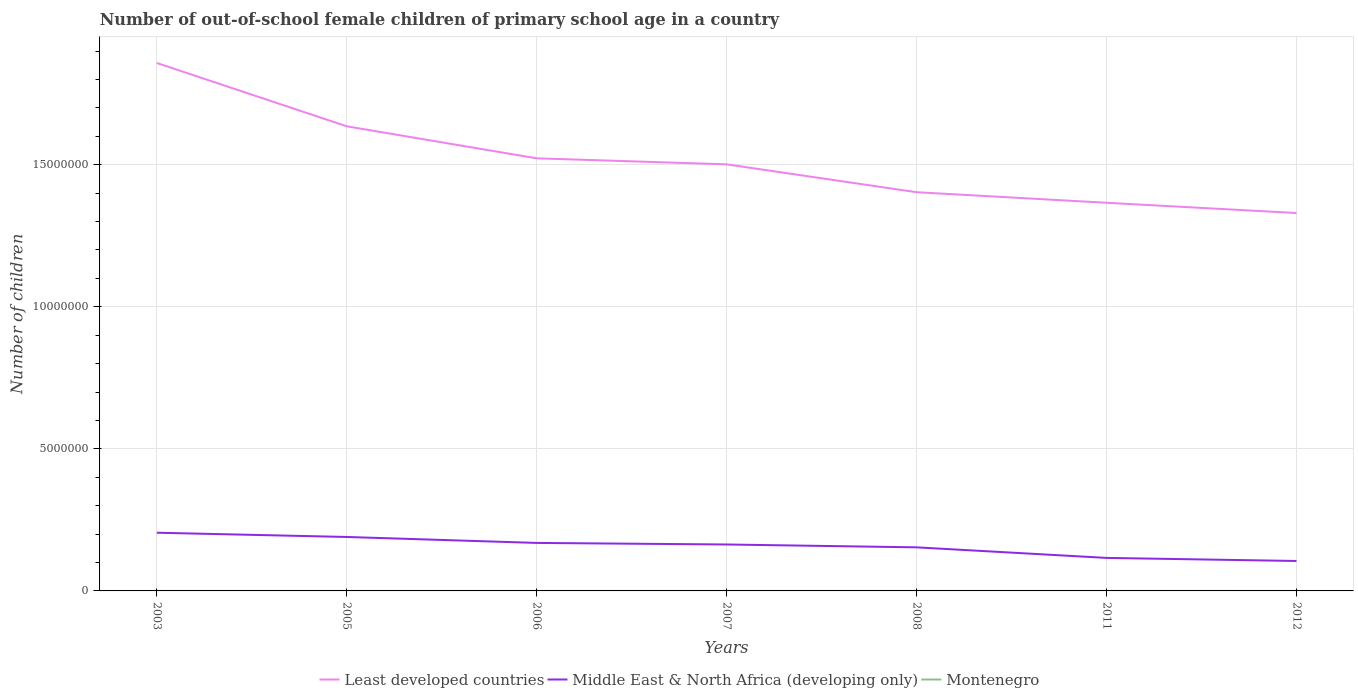Across all years, what is the maximum number of out-of-school female children in Least developed countries?
Give a very brief answer. 1.33e+07. In which year was the number of out-of-school female children in Middle East & North Africa (developing only) maximum?
Ensure brevity in your answer.  2012. What is the total number of out-of-school female children in Montenegro in the graph?
Your answer should be compact. -806. What is the difference between the highest and the second highest number of out-of-school female children in Montenegro?
Give a very brief answer. 1319. Is the number of out-of-school female children in Least developed countries strictly greater than the number of out-of-school female children in Middle East & North Africa (developing only) over the years?
Ensure brevity in your answer.  No. What is the difference between two consecutive major ticks on the Y-axis?
Your answer should be compact. 5.00e+06. Are the values on the major ticks of Y-axis written in scientific E-notation?
Your response must be concise. No. Does the graph contain grids?
Give a very brief answer. Yes. Where does the legend appear in the graph?
Ensure brevity in your answer.  Bottom center. How many legend labels are there?
Your response must be concise. 3. How are the legend labels stacked?
Keep it short and to the point. Horizontal. What is the title of the graph?
Offer a terse response. Number of out-of-school female children of primary school age in a country. What is the label or title of the X-axis?
Make the answer very short. Years. What is the label or title of the Y-axis?
Your answer should be very brief. Number of children. What is the Number of children of Least developed countries in 2003?
Provide a succinct answer. 1.86e+07. What is the Number of children of Middle East & North Africa (developing only) in 2003?
Make the answer very short. 2.05e+06. What is the Number of children in Montenegro in 2003?
Give a very brief answer. 666. What is the Number of children in Least developed countries in 2005?
Give a very brief answer. 1.64e+07. What is the Number of children of Middle East & North Africa (developing only) in 2005?
Your response must be concise. 1.90e+06. What is the Number of children of Montenegro in 2005?
Provide a short and direct response. 396. What is the Number of children in Least developed countries in 2006?
Ensure brevity in your answer.  1.52e+07. What is the Number of children in Middle East & North Africa (developing only) in 2006?
Ensure brevity in your answer.  1.69e+06. What is the Number of children of Montenegro in 2006?
Make the answer very short. 362. What is the Number of children in Least developed countries in 2007?
Give a very brief answer. 1.50e+07. What is the Number of children in Middle East & North Africa (developing only) in 2007?
Your answer should be very brief. 1.63e+06. What is the Number of children in Montenegro in 2007?
Give a very brief answer. 685. What is the Number of children of Least developed countries in 2008?
Ensure brevity in your answer.  1.40e+07. What is the Number of children of Middle East & North Africa (developing only) in 2008?
Give a very brief answer. 1.53e+06. What is the Number of children in Montenegro in 2008?
Your response must be concise. 690. What is the Number of children in Least developed countries in 2011?
Offer a very short reply. 1.37e+07. What is the Number of children of Middle East & North Africa (developing only) in 2011?
Your answer should be compact. 1.16e+06. What is the Number of children of Montenegro in 2011?
Provide a succinct answer. 1491. What is the Number of children of Least developed countries in 2012?
Make the answer very short. 1.33e+07. What is the Number of children in Middle East & North Africa (developing only) in 2012?
Offer a terse response. 1.05e+06. What is the Number of children in Montenegro in 2012?
Keep it short and to the point. 172. Across all years, what is the maximum Number of children of Least developed countries?
Provide a succinct answer. 1.86e+07. Across all years, what is the maximum Number of children in Middle East & North Africa (developing only)?
Offer a terse response. 2.05e+06. Across all years, what is the maximum Number of children in Montenegro?
Offer a terse response. 1491. Across all years, what is the minimum Number of children in Least developed countries?
Offer a very short reply. 1.33e+07. Across all years, what is the minimum Number of children of Middle East & North Africa (developing only)?
Your answer should be compact. 1.05e+06. Across all years, what is the minimum Number of children in Montenegro?
Make the answer very short. 172. What is the total Number of children in Least developed countries in the graph?
Offer a terse response. 1.06e+08. What is the total Number of children of Middle East & North Africa (developing only) in the graph?
Give a very brief answer. 1.10e+07. What is the total Number of children in Montenegro in the graph?
Provide a succinct answer. 4462. What is the difference between the Number of children in Least developed countries in 2003 and that in 2005?
Provide a short and direct response. 2.23e+06. What is the difference between the Number of children in Middle East & North Africa (developing only) in 2003 and that in 2005?
Ensure brevity in your answer.  1.49e+05. What is the difference between the Number of children of Montenegro in 2003 and that in 2005?
Offer a very short reply. 270. What is the difference between the Number of children of Least developed countries in 2003 and that in 2006?
Your response must be concise. 3.36e+06. What is the difference between the Number of children in Middle East & North Africa (developing only) in 2003 and that in 2006?
Offer a terse response. 3.59e+05. What is the difference between the Number of children in Montenegro in 2003 and that in 2006?
Offer a very short reply. 304. What is the difference between the Number of children of Least developed countries in 2003 and that in 2007?
Keep it short and to the point. 3.57e+06. What is the difference between the Number of children of Middle East & North Africa (developing only) in 2003 and that in 2007?
Offer a terse response. 4.14e+05. What is the difference between the Number of children of Least developed countries in 2003 and that in 2008?
Make the answer very short. 4.55e+06. What is the difference between the Number of children of Middle East & North Africa (developing only) in 2003 and that in 2008?
Your answer should be very brief. 5.14e+05. What is the difference between the Number of children in Least developed countries in 2003 and that in 2011?
Make the answer very short. 4.92e+06. What is the difference between the Number of children of Middle East & North Africa (developing only) in 2003 and that in 2011?
Provide a succinct answer. 8.86e+05. What is the difference between the Number of children in Montenegro in 2003 and that in 2011?
Keep it short and to the point. -825. What is the difference between the Number of children of Least developed countries in 2003 and that in 2012?
Give a very brief answer. 5.28e+06. What is the difference between the Number of children of Middle East & North Africa (developing only) in 2003 and that in 2012?
Make the answer very short. 9.95e+05. What is the difference between the Number of children of Montenegro in 2003 and that in 2012?
Offer a terse response. 494. What is the difference between the Number of children of Least developed countries in 2005 and that in 2006?
Provide a short and direct response. 1.13e+06. What is the difference between the Number of children in Middle East & North Africa (developing only) in 2005 and that in 2006?
Your response must be concise. 2.09e+05. What is the difference between the Number of children in Least developed countries in 2005 and that in 2007?
Give a very brief answer. 1.34e+06. What is the difference between the Number of children in Middle East & North Africa (developing only) in 2005 and that in 2007?
Give a very brief answer. 2.65e+05. What is the difference between the Number of children in Montenegro in 2005 and that in 2007?
Your response must be concise. -289. What is the difference between the Number of children in Least developed countries in 2005 and that in 2008?
Keep it short and to the point. 2.32e+06. What is the difference between the Number of children in Middle East & North Africa (developing only) in 2005 and that in 2008?
Offer a very short reply. 3.65e+05. What is the difference between the Number of children of Montenegro in 2005 and that in 2008?
Your response must be concise. -294. What is the difference between the Number of children in Least developed countries in 2005 and that in 2011?
Your answer should be compact. 2.69e+06. What is the difference between the Number of children of Middle East & North Africa (developing only) in 2005 and that in 2011?
Provide a short and direct response. 7.37e+05. What is the difference between the Number of children in Montenegro in 2005 and that in 2011?
Your response must be concise. -1095. What is the difference between the Number of children in Least developed countries in 2005 and that in 2012?
Ensure brevity in your answer.  3.05e+06. What is the difference between the Number of children in Middle East & North Africa (developing only) in 2005 and that in 2012?
Provide a short and direct response. 8.45e+05. What is the difference between the Number of children of Montenegro in 2005 and that in 2012?
Provide a succinct answer. 224. What is the difference between the Number of children in Least developed countries in 2006 and that in 2007?
Keep it short and to the point. 2.11e+05. What is the difference between the Number of children in Middle East & North Africa (developing only) in 2006 and that in 2007?
Offer a very short reply. 5.52e+04. What is the difference between the Number of children in Montenegro in 2006 and that in 2007?
Give a very brief answer. -323. What is the difference between the Number of children in Least developed countries in 2006 and that in 2008?
Ensure brevity in your answer.  1.19e+06. What is the difference between the Number of children of Middle East & North Africa (developing only) in 2006 and that in 2008?
Make the answer very short. 1.56e+05. What is the difference between the Number of children in Montenegro in 2006 and that in 2008?
Provide a short and direct response. -328. What is the difference between the Number of children of Least developed countries in 2006 and that in 2011?
Provide a short and direct response. 1.56e+06. What is the difference between the Number of children in Middle East & North Africa (developing only) in 2006 and that in 2011?
Your response must be concise. 5.27e+05. What is the difference between the Number of children of Montenegro in 2006 and that in 2011?
Your answer should be very brief. -1129. What is the difference between the Number of children in Least developed countries in 2006 and that in 2012?
Provide a short and direct response. 1.93e+06. What is the difference between the Number of children of Middle East & North Africa (developing only) in 2006 and that in 2012?
Provide a succinct answer. 6.36e+05. What is the difference between the Number of children in Montenegro in 2006 and that in 2012?
Offer a terse response. 190. What is the difference between the Number of children in Least developed countries in 2007 and that in 2008?
Your answer should be very brief. 9.81e+05. What is the difference between the Number of children in Middle East & North Africa (developing only) in 2007 and that in 2008?
Give a very brief answer. 1.00e+05. What is the difference between the Number of children of Montenegro in 2007 and that in 2008?
Your answer should be very brief. -5. What is the difference between the Number of children of Least developed countries in 2007 and that in 2011?
Make the answer very short. 1.35e+06. What is the difference between the Number of children of Middle East & North Africa (developing only) in 2007 and that in 2011?
Make the answer very short. 4.72e+05. What is the difference between the Number of children of Montenegro in 2007 and that in 2011?
Your response must be concise. -806. What is the difference between the Number of children of Least developed countries in 2007 and that in 2012?
Offer a terse response. 1.71e+06. What is the difference between the Number of children in Middle East & North Africa (developing only) in 2007 and that in 2012?
Make the answer very short. 5.81e+05. What is the difference between the Number of children in Montenegro in 2007 and that in 2012?
Give a very brief answer. 513. What is the difference between the Number of children of Least developed countries in 2008 and that in 2011?
Your answer should be compact. 3.72e+05. What is the difference between the Number of children in Middle East & North Africa (developing only) in 2008 and that in 2011?
Give a very brief answer. 3.72e+05. What is the difference between the Number of children in Montenegro in 2008 and that in 2011?
Keep it short and to the point. -801. What is the difference between the Number of children in Least developed countries in 2008 and that in 2012?
Your answer should be compact. 7.33e+05. What is the difference between the Number of children of Middle East & North Africa (developing only) in 2008 and that in 2012?
Provide a succinct answer. 4.80e+05. What is the difference between the Number of children of Montenegro in 2008 and that in 2012?
Ensure brevity in your answer.  518. What is the difference between the Number of children in Least developed countries in 2011 and that in 2012?
Give a very brief answer. 3.61e+05. What is the difference between the Number of children of Middle East & North Africa (developing only) in 2011 and that in 2012?
Offer a terse response. 1.09e+05. What is the difference between the Number of children in Montenegro in 2011 and that in 2012?
Give a very brief answer. 1319. What is the difference between the Number of children of Least developed countries in 2003 and the Number of children of Middle East & North Africa (developing only) in 2005?
Offer a very short reply. 1.67e+07. What is the difference between the Number of children of Least developed countries in 2003 and the Number of children of Montenegro in 2005?
Offer a terse response. 1.86e+07. What is the difference between the Number of children of Middle East & North Africa (developing only) in 2003 and the Number of children of Montenegro in 2005?
Offer a very short reply. 2.05e+06. What is the difference between the Number of children of Least developed countries in 2003 and the Number of children of Middle East & North Africa (developing only) in 2006?
Provide a short and direct response. 1.69e+07. What is the difference between the Number of children in Least developed countries in 2003 and the Number of children in Montenegro in 2006?
Offer a very short reply. 1.86e+07. What is the difference between the Number of children in Middle East & North Africa (developing only) in 2003 and the Number of children in Montenegro in 2006?
Offer a very short reply. 2.05e+06. What is the difference between the Number of children of Least developed countries in 2003 and the Number of children of Middle East & North Africa (developing only) in 2007?
Your answer should be compact. 1.69e+07. What is the difference between the Number of children of Least developed countries in 2003 and the Number of children of Montenegro in 2007?
Offer a very short reply. 1.86e+07. What is the difference between the Number of children in Middle East & North Africa (developing only) in 2003 and the Number of children in Montenegro in 2007?
Give a very brief answer. 2.05e+06. What is the difference between the Number of children in Least developed countries in 2003 and the Number of children in Middle East & North Africa (developing only) in 2008?
Give a very brief answer. 1.70e+07. What is the difference between the Number of children of Least developed countries in 2003 and the Number of children of Montenegro in 2008?
Keep it short and to the point. 1.86e+07. What is the difference between the Number of children in Middle East & North Africa (developing only) in 2003 and the Number of children in Montenegro in 2008?
Offer a very short reply. 2.05e+06. What is the difference between the Number of children of Least developed countries in 2003 and the Number of children of Middle East & North Africa (developing only) in 2011?
Offer a terse response. 1.74e+07. What is the difference between the Number of children of Least developed countries in 2003 and the Number of children of Montenegro in 2011?
Give a very brief answer. 1.86e+07. What is the difference between the Number of children of Middle East & North Africa (developing only) in 2003 and the Number of children of Montenegro in 2011?
Keep it short and to the point. 2.05e+06. What is the difference between the Number of children of Least developed countries in 2003 and the Number of children of Middle East & North Africa (developing only) in 2012?
Keep it short and to the point. 1.75e+07. What is the difference between the Number of children of Least developed countries in 2003 and the Number of children of Montenegro in 2012?
Offer a very short reply. 1.86e+07. What is the difference between the Number of children in Middle East & North Africa (developing only) in 2003 and the Number of children in Montenegro in 2012?
Your answer should be compact. 2.05e+06. What is the difference between the Number of children in Least developed countries in 2005 and the Number of children in Middle East & North Africa (developing only) in 2006?
Keep it short and to the point. 1.47e+07. What is the difference between the Number of children in Least developed countries in 2005 and the Number of children in Montenegro in 2006?
Your response must be concise. 1.64e+07. What is the difference between the Number of children in Middle East & North Africa (developing only) in 2005 and the Number of children in Montenegro in 2006?
Keep it short and to the point. 1.90e+06. What is the difference between the Number of children of Least developed countries in 2005 and the Number of children of Middle East & North Africa (developing only) in 2007?
Offer a terse response. 1.47e+07. What is the difference between the Number of children in Least developed countries in 2005 and the Number of children in Montenegro in 2007?
Ensure brevity in your answer.  1.64e+07. What is the difference between the Number of children in Middle East & North Africa (developing only) in 2005 and the Number of children in Montenegro in 2007?
Offer a very short reply. 1.90e+06. What is the difference between the Number of children in Least developed countries in 2005 and the Number of children in Middle East & North Africa (developing only) in 2008?
Make the answer very short. 1.48e+07. What is the difference between the Number of children of Least developed countries in 2005 and the Number of children of Montenegro in 2008?
Offer a very short reply. 1.64e+07. What is the difference between the Number of children in Middle East & North Africa (developing only) in 2005 and the Number of children in Montenegro in 2008?
Ensure brevity in your answer.  1.90e+06. What is the difference between the Number of children of Least developed countries in 2005 and the Number of children of Middle East & North Africa (developing only) in 2011?
Keep it short and to the point. 1.52e+07. What is the difference between the Number of children in Least developed countries in 2005 and the Number of children in Montenegro in 2011?
Your answer should be compact. 1.63e+07. What is the difference between the Number of children of Middle East & North Africa (developing only) in 2005 and the Number of children of Montenegro in 2011?
Your response must be concise. 1.90e+06. What is the difference between the Number of children in Least developed countries in 2005 and the Number of children in Middle East & North Africa (developing only) in 2012?
Provide a short and direct response. 1.53e+07. What is the difference between the Number of children in Least developed countries in 2005 and the Number of children in Montenegro in 2012?
Your response must be concise. 1.64e+07. What is the difference between the Number of children of Middle East & North Africa (developing only) in 2005 and the Number of children of Montenegro in 2012?
Your answer should be very brief. 1.90e+06. What is the difference between the Number of children of Least developed countries in 2006 and the Number of children of Middle East & North Africa (developing only) in 2007?
Provide a short and direct response. 1.36e+07. What is the difference between the Number of children in Least developed countries in 2006 and the Number of children in Montenegro in 2007?
Offer a very short reply. 1.52e+07. What is the difference between the Number of children in Middle East & North Africa (developing only) in 2006 and the Number of children in Montenegro in 2007?
Provide a succinct answer. 1.69e+06. What is the difference between the Number of children in Least developed countries in 2006 and the Number of children in Middle East & North Africa (developing only) in 2008?
Give a very brief answer. 1.37e+07. What is the difference between the Number of children in Least developed countries in 2006 and the Number of children in Montenegro in 2008?
Your answer should be very brief. 1.52e+07. What is the difference between the Number of children in Middle East & North Africa (developing only) in 2006 and the Number of children in Montenegro in 2008?
Offer a terse response. 1.69e+06. What is the difference between the Number of children in Least developed countries in 2006 and the Number of children in Middle East & North Africa (developing only) in 2011?
Your answer should be very brief. 1.41e+07. What is the difference between the Number of children in Least developed countries in 2006 and the Number of children in Montenegro in 2011?
Offer a terse response. 1.52e+07. What is the difference between the Number of children in Middle East & North Africa (developing only) in 2006 and the Number of children in Montenegro in 2011?
Ensure brevity in your answer.  1.69e+06. What is the difference between the Number of children of Least developed countries in 2006 and the Number of children of Middle East & North Africa (developing only) in 2012?
Provide a succinct answer. 1.42e+07. What is the difference between the Number of children in Least developed countries in 2006 and the Number of children in Montenegro in 2012?
Provide a succinct answer. 1.52e+07. What is the difference between the Number of children of Middle East & North Africa (developing only) in 2006 and the Number of children of Montenegro in 2012?
Your answer should be compact. 1.69e+06. What is the difference between the Number of children in Least developed countries in 2007 and the Number of children in Middle East & North Africa (developing only) in 2008?
Your answer should be very brief. 1.35e+07. What is the difference between the Number of children in Least developed countries in 2007 and the Number of children in Montenegro in 2008?
Your answer should be very brief. 1.50e+07. What is the difference between the Number of children of Middle East & North Africa (developing only) in 2007 and the Number of children of Montenegro in 2008?
Keep it short and to the point. 1.63e+06. What is the difference between the Number of children in Least developed countries in 2007 and the Number of children in Middle East & North Africa (developing only) in 2011?
Offer a terse response. 1.39e+07. What is the difference between the Number of children in Least developed countries in 2007 and the Number of children in Montenegro in 2011?
Give a very brief answer. 1.50e+07. What is the difference between the Number of children of Middle East & North Africa (developing only) in 2007 and the Number of children of Montenegro in 2011?
Your response must be concise. 1.63e+06. What is the difference between the Number of children in Least developed countries in 2007 and the Number of children in Middle East & North Africa (developing only) in 2012?
Give a very brief answer. 1.40e+07. What is the difference between the Number of children in Least developed countries in 2007 and the Number of children in Montenegro in 2012?
Ensure brevity in your answer.  1.50e+07. What is the difference between the Number of children in Middle East & North Africa (developing only) in 2007 and the Number of children in Montenegro in 2012?
Give a very brief answer. 1.63e+06. What is the difference between the Number of children of Least developed countries in 2008 and the Number of children of Middle East & North Africa (developing only) in 2011?
Offer a terse response. 1.29e+07. What is the difference between the Number of children of Least developed countries in 2008 and the Number of children of Montenegro in 2011?
Make the answer very short. 1.40e+07. What is the difference between the Number of children of Middle East & North Africa (developing only) in 2008 and the Number of children of Montenegro in 2011?
Offer a terse response. 1.53e+06. What is the difference between the Number of children of Least developed countries in 2008 and the Number of children of Middle East & North Africa (developing only) in 2012?
Your answer should be compact. 1.30e+07. What is the difference between the Number of children of Least developed countries in 2008 and the Number of children of Montenegro in 2012?
Keep it short and to the point. 1.40e+07. What is the difference between the Number of children of Middle East & North Africa (developing only) in 2008 and the Number of children of Montenegro in 2012?
Make the answer very short. 1.53e+06. What is the difference between the Number of children in Least developed countries in 2011 and the Number of children in Middle East & North Africa (developing only) in 2012?
Offer a terse response. 1.26e+07. What is the difference between the Number of children in Least developed countries in 2011 and the Number of children in Montenegro in 2012?
Your response must be concise. 1.37e+07. What is the difference between the Number of children of Middle East & North Africa (developing only) in 2011 and the Number of children of Montenegro in 2012?
Ensure brevity in your answer.  1.16e+06. What is the average Number of children in Least developed countries per year?
Your answer should be compact. 1.52e+07. What is the average Number of children in Middle East & North Africa (developing only) per year?
Make the answer very short. 1.57e+06. What is the average Number of children in Montenegro per year?
Provide a succinct answer. 637.43. In the year 2003, what is the difference between the Number of children of Least developed countries and Number of children of Middle East & North Africa (developing only)?
Give a very brief answer. 1.65e+07. In the year 2003, what is the difference between the Number of children of Least developed countries and Number of children of Montenegro?
Provide a succinct answer. 1.86e+07. In the year 2003, what is the difference between the Number of children in Middle East & North Africa (developing only) and Number of children in Montenegro?
Ensure brevity in your answer.  2.05e+06. In the year 2005, what is the difference between the Number of children of Least developed countries and Number of children of Middle East & North Africa (developing only)?
Make the answer very short. 1.45e+07. In the year 2005, what is the difference between the Number of children of Least developed countries and Number of children of Montenegro?
Ensure brevity in your answer.  1.64e+07. In the year 2005, what is the difference between the Number of children of Middle East & North Africa (developing only) and Number of children of Montenegro?
Give a very brief answer. 1.90e+06. In the year 2006, what is the difference between the Number of children of Least developed countries and Number of children of Middle East & North Africa (developing only)?
Your answer should be compact. 1.35e+07. In the year 2006, what is the difference between the Number of children of Least developed countries and Number of children of Montenegro?
Offer a terse response. 1.52e+07. In the year 2006, what is the difference between the Number of children of Middle East & North Africa (developing only) and Number of children of Montenegro?
Your response must be concise. 1.69e+06. In the year 2007, what is the difference between the Number of children of Least developed countries and Number of children of Middle East & North Africa (developing only)?
Keep it short and to the point. 1.34e+07. In the year 2007, what is the difference between the Number of children in Least developed countries and Number of children in Montenegro?
Keep it short and to the point. 1.50e+07. In the year 2007, what is the difference between the Number of children of Middle East & North Africa (developing only) and Number of children of Montenegro?
Your answer should be very brief. 1.63e+06. In the year 2008, what is the difference between the Number of children of Least developed countries and Number of children of Middle East & North Africa (developing only)?
Offer a very short reply. 1.25e+07. In the year 2008, what is the difference between the Number of children in Least developed countries and Number of children in Montenegro?
Give a very brief answer. 1.40e+07. In the year 2008, what is the difference between the Number of children in Middle East & North Africa (developing only) and Number of children in Montenegro?
Ensure brevity in your answer.  1.53e+06. In the year 2011, what is the difference between the Number of children in Least developed countries and Number of children in Middle East & North Africa (developing only)?
Ensure brevity in your answer.  1.25e+07. In the year 2011, what is the difference between the Number of children in Least developed countries and Number of children in Montenegro?
Provide a succinct answer. 1.37e+07. In the year 2011, what is the difference between the Number of children of Middle East & North Africa (developing only) and Number of children of Montenegro?
Keep it short and to the point. 1.16e+06. In the year 2012, what is the difference between the Number of children of Least developed countries and Number of children of Middle East & North Africa (developing only)?
Your answer should be compact. 1.22e+07. In the year 2012, what is the difference between the Number of children of Least developed countries and Number of children of Montenegro?
Your answer should be compact. 1.33e+07. In the year 2012, what is the difference between the Number of children of Middle East & North Africa (developing only) and Number of children of Montenegro?
Ensure brevity in your answer.  1.05e+06. What is the ratio of the Number of children in Least developed countries in 2003 to that in 2005?
Your answer should be very brief. 1.14. What is the ratio of the Number of children of Middle East & North Africa (developing only) in 2003 to that in 2005?
Your answer should be compact. 1.08. What is the ratio of the Number of children in Montenegro in 2003 to that in 2005?
Provide a short and direct response. 1.68. What is the ratio of the Number of children of Least developed countries in 2003 to that in 2006?
Ensure brevity in your answer.  1.22. What is the ratio of the Number of children in Middle East & North Africa (developing only) in 2003 to that in 2006?
Provide a short and direct response. 1.21. What is the ratio of the Number of children in Montenegro in 2003 to that in 2006?
Offer a terse response. 1.84. What is the ratio of the Number of children of Least developed countries in 2003 to that in 2007?
Ensure brevity in your answer.  1.24. What is the ratio of the Number of children of Middle East & North Africa (developing only) in 2003 to that in 2007?
Your answer should be compact. 1.25. What is the ratio of the Number of children in Montenegro in 2003 to that in 2007?
Ensure brevity in your answer.  0.97. What is the ratio of the Number of children in Least developed countries in 2003 to that in 2008?
Offer a very short reply. 1.32. What is the ratio of the Number of children in Middle East & North Africa (developing only) in 2003 to that in 2008?
Ensure brevity in your answer.  1.34. What is the ratio of the Number of children of Montenegro in 2003 to that in 2008?
Make the answer very short. 0.97. What is the ratio of the Number of children in Least developed countries in 2003 to that in 2011?
Keep it short and to the point. 1.36. What is the ratio of the Number of children of Middle East & North Africa (developing only) in 2003 to that in 2011?
Give a very brief answer. 1.76. What is the ratio of the Number of children in Montenegro in 2003 to that in 2011?
Keep it short and to the point. 0.45. What is the ratio of the Number of children in Least developed countries in 2003 to that in 2012?
Provide a succinct answer. 1.4. What is the ratio of the Number of children of Middle East & North Africa (developing only) in 2003 to that in 2012?
Your response must be concise. 1.94. What is the ratio of the Number of children in Montenegro in 2003 to that in 2012?
Provide a short and direct response. 3.87. What is the ratio of the Number of children in Least developed countries in 2005 to that in 2006?
Offer a very short reply. 1.07. What is the ratio of the Number of children of Middle East & North Africa (developing only) in 2005 to that in 2006?
Provide a short and direct response. 1.12. What is the ratio of the Number of children in Montenegro in 2005 to that in 2006?
Your response must be concise. 1.09. What is the ratio of the Number of children in Least developed countries in 2005 to that in 2007?
Ensure brevity in your answer.  1.09. What is the ratio of the Number of children of Middle East & North Africa (developing only) in 2005 to that in 2007?
Offer a terse response. 1.16. What is the ratio of the Number of children of Montenegro in 2005 to that in 2007?
Make the answer very short. 0.58. What is the ratio of the Number of children in Least developed countries in 2005 to that in 2008?
Your answer should be compact. 1.17. What is the ratio of the Number of children of Middle East & North Africa (developing only) in 2005 to that in 2008?
Make the answer very short. 1.24. What is the ratio of the Number of children in Montenegro in 2005 to that in 2008?
Keep it short and to the point. 0.57. What is the ratio of the Number of children in Least developed countries in 2005 to that in 2011?
Make the answer very short. 1.2. What is the ratio of the Number of children of Middle East & North Africa (developing only) in 2005 to that in 2011?
Make the answer very short. 1.63. What is the ratio of the Number of children of Montenegro in 2005 to that in 2011?
Keep it short and to the point. 0.27. What is the ratio of the Number of children of Least developed countries in 2005 to that in 2012?
Make the answer very short. 1.23. What is the ratio of the Number of children of Middle East & North Africa (developing only) in 2005 to that in 2012?
Your answer should be compact. 1.8. What is the ratio of the Number of children in Montenegro in 2005 to that in 2012?
Give a very brief answer. 2.3. What is the ratio of the Number of children of Least developed countries in 2006 to that in 2007?
Keep it short and to the point. 1.01. What is the ratio of the Number of children of Middle East & North Africa (developing only) in 2006 to that in 2007?
Your response must be concise. 1.03. What is the ratio of the Number of children of Montenegro in 2006 to that in 2007?
Make the answer very short. 0.53. What is the ratio of the Number of children in Least developed countries in 2006 to that in 2008?
Ensure brevity in your answer.  1.08. What is the ratio of the Number of children in Middle East & North Africa (developing only) in 2006 to that in 2008?
Give a very brief answer. 1.1. What is the ratio of the Number of children of Montenegro in 2006 to that in 2008?
Offer a very short reply. 0.52. What is the ratio of the Number of children in Least developed countries in 2006 to that in 2011?
Keep it short and to the point. 1.11. What is the ratio of the Number of children of Middle East & North Africa (developing only) in 2006 to that in 2011?
Provide a succinct answer. 1.45. What is the ratio of the Number of children in Montenegro in 2006 to that in 2011?
Make the answer very short. 0.24. What is the ratio of the Number of children in Least developed countries in 2006 to that in 2012?
Provide a short and direct response. 1.14. What is the ratio of the Number of children of Middle East & North Africa (developing only) in 2006 to that in 2012?
Offer a terse response. 1.6. What is the ratio of the Number of children of Montenegro in 2006 to that in 2012?
Ensure brevity in your answer.  2.1. What is the ratio of the Number of children in Least developed countries in 2007 to that in 2008?
Give a very brief answer. 1.07. What is the ratio of the Number of children in Middle East & North Africa (developing only) in 2007 to that in 2008?
Keep it short and to the point. 1.07. What is the ratio of the Number of children of Least developed countries in 2007 to that in 2011?
Your response must be concise. 1.1. What is the ratio of the Number of children of Middle East & North Africa (developing only) in 2007 to that in 2011?
Make the answer very short. 1.41. What is the ratio of the Number of children in Montenegro in 2007 to that in 2011?
Give a very brief answer. 0.46. What is the ratio of the Number of children of Least developed countries in 2007 to that in 2012?
Make the answer very short. 1.13. What is the ratio of the Number of children of Middle East & North Africa (developing only) in 2007 to that in 2012?
Keep it short and to the point. 1.55. What is the ratio of the Number of children of Montenegro in 2007 to that in 2012?
Provide a short and direct response. 3.98. What is the ratio of the Number of children in Least developed countries in 2008 to that in 2011?
Offer a very short reply. 1.03. What is the ratio of the Number of children in Middle East & North Africa (developing only) in 2008 to that in 2011?
Provide a succinct answer. 1.32. What is the ratio of the Number of children in Montenegro in 2008 to that in 2011?
Make the answer very short. 0.46. What is the ratio of the Number of children of Least developed countries in 2008 to that in 2012?
Ensure brevity in your answer.  1.06. What is the ratio of the Number of children of Middle East & North Africa (developing only) in 2008 to that in 2012?
Offer a terse response. 1.46. What is the ratio of the Number of children in Montenegro in 2008 to that in 2012?
Your response must be concise. 4.01. What is the ratio of the Number of children of Least developed countries in 2011 to that in 2012?
Your response must be concise. 1.03. What is the ratio of the Number of children in Middle East & North Africa (developing only) in 2011 to that in 2012?
Offer a very short reply. 1.1. What is the ratio of the Number of children of Montenegro in 2011 to that in 2012?
Give a very brief answer. 8.67. What is the difference between the highest and the second highest Number of children in Least developed countries?
Offer a terse response. 2.23e+06. What is the difference between the highest and the second highest Number of children of Middle East & North Africa (developing only)?
Give a very brief answer. 1.49e+05. What is the difference between the highest and the second highest Number of children of Montenegro?
Offer a terse response. 801. What is the difference between the highest and the lowest Number of children of Least developed countries?
Ensure brevity in your answer.  5.28e+06. What is the difference between the highest and the lowest Number of children in Middle East & North Africa (developing only)?
Give a very brief answer. 9.95e+05. What is the difference between the highest and the lowest Number of children of Montenegro?
Provide a short and direct response. 1319. 